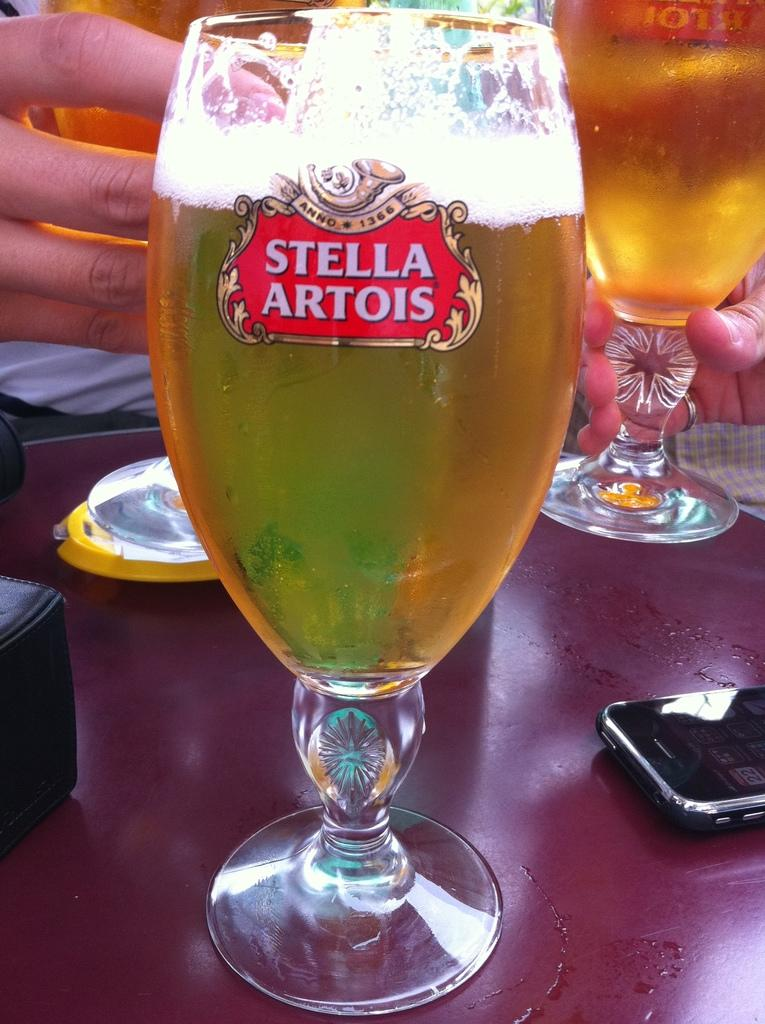<image>
Write a terse but informative summary of the picture. A glass of beer with Stella Artois on it. 